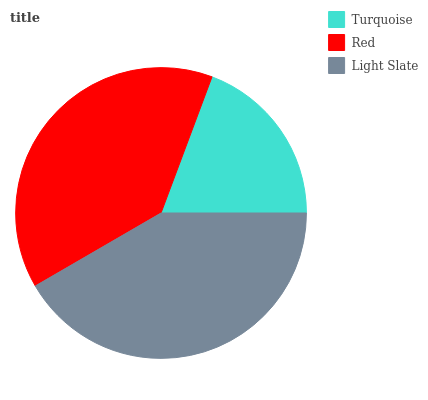Is Turquoise the minimum?
Answer yes or no. Yes. Is Light Slate the maximum?
Answer yes or no. Yes. Is Red the minimum?
Answer yes or no. No. Is Red the maximum?
Answer yes or no. No. Is Red greater than Turquoise?
Answer yes or no. Yes. Is Turquoise less than Red?
Answer yes or no. Yes. Is Turquoise greater than Red?
Answer yes or no. No. Is Red less than Turquoise?
Answer yes or no. No. Is Red the high median?
Answer yes or no. Yes. Is Red the low median?
Answer yes or no. Yes. Is Turquoise the high median?
Answer yes or no. No. Is Light Slate the low median?
Answer yes or no. No. 